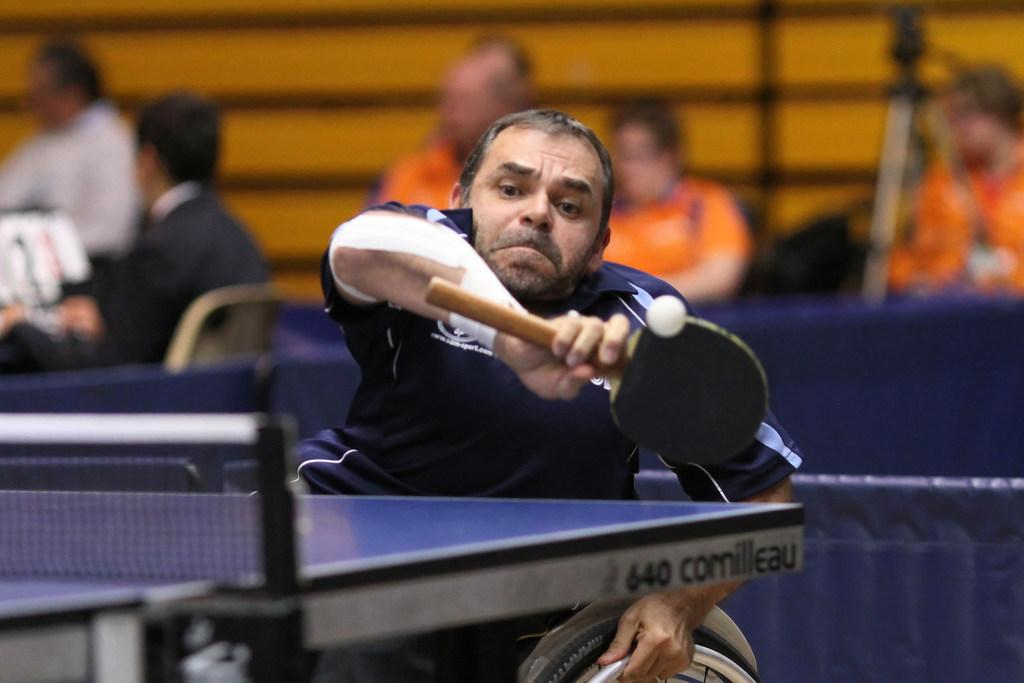Who is the main subject in the image? There is a person in the image. What is the person's position in the image? The person is sitting on a wheelchair. What activity is the person engaged in? The person is playing a game. What object is the person holding in the image? The person is holding a bat. How many toes can be seen on the person's feet in the image? The image does not show the person's feet, so the number of toes cannot be determined. 